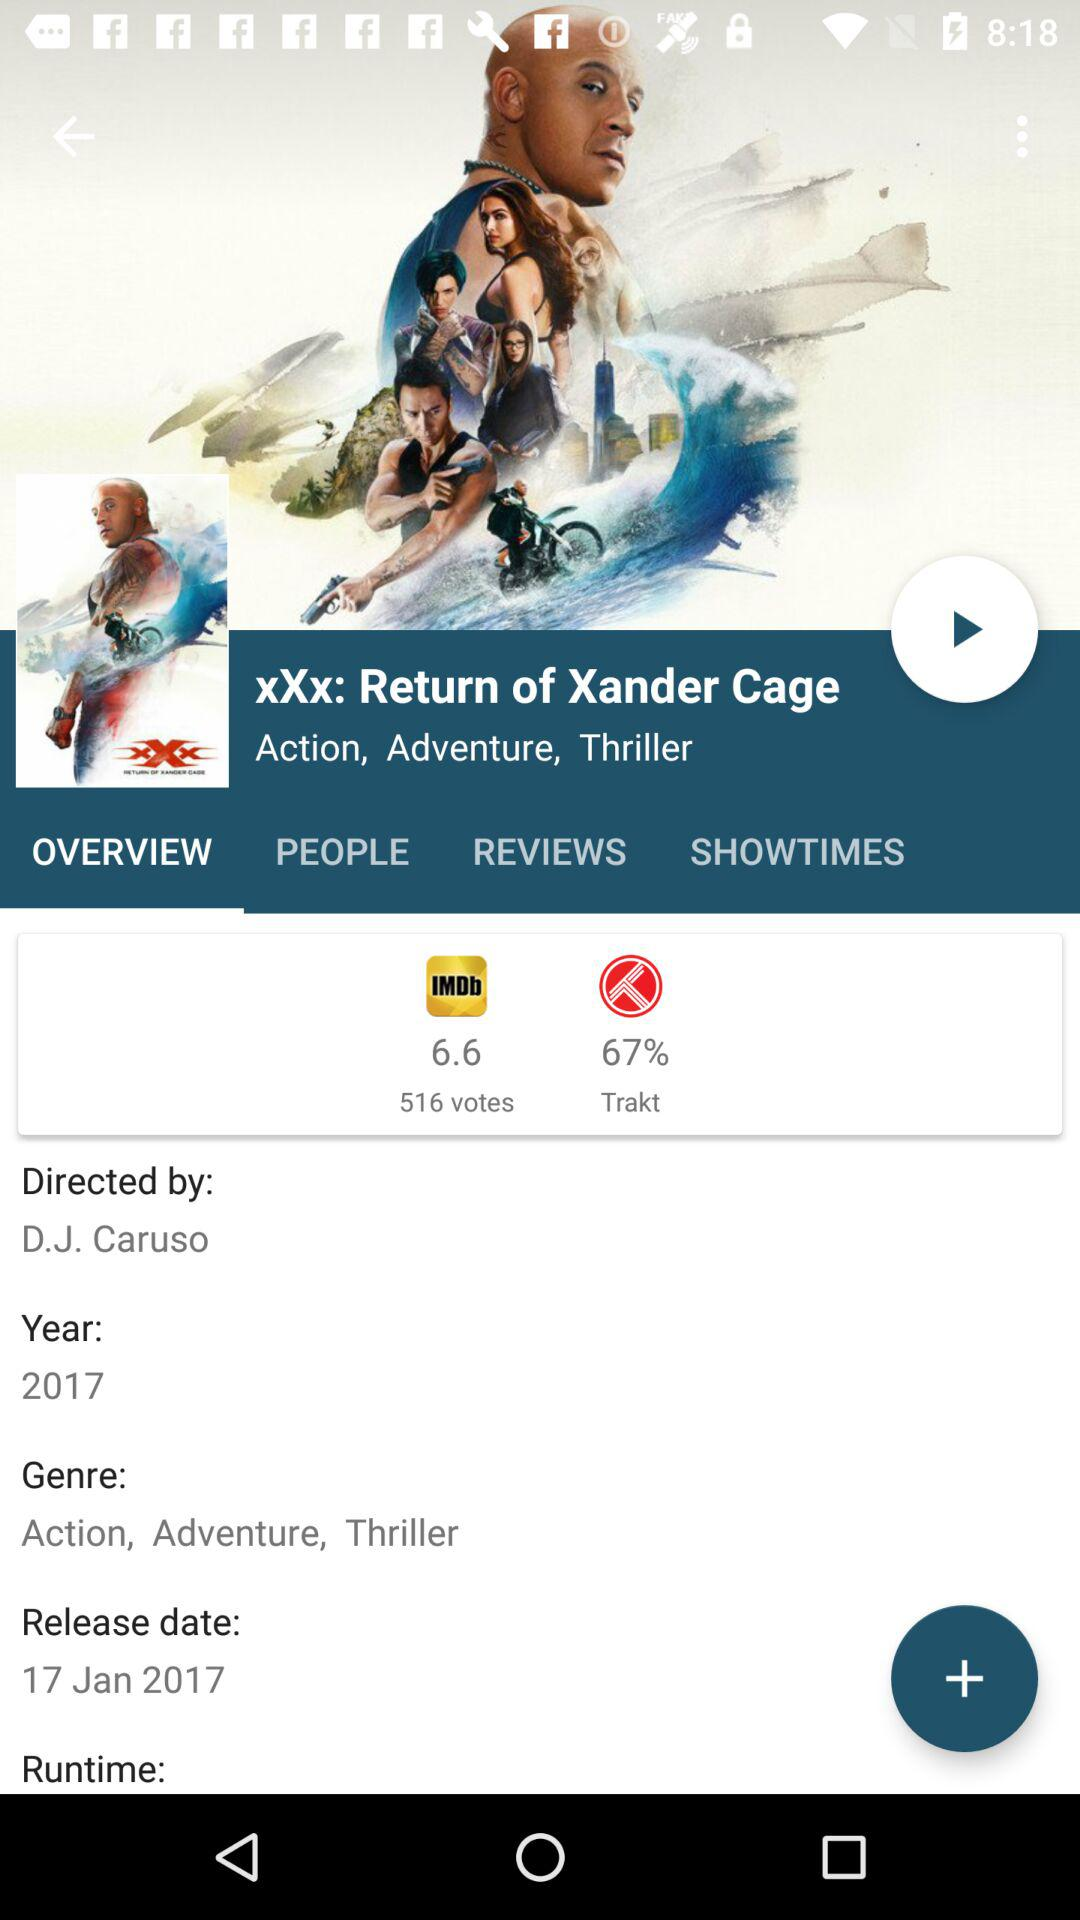Who is the director of the movie? The director is " D.J. Caruso". 